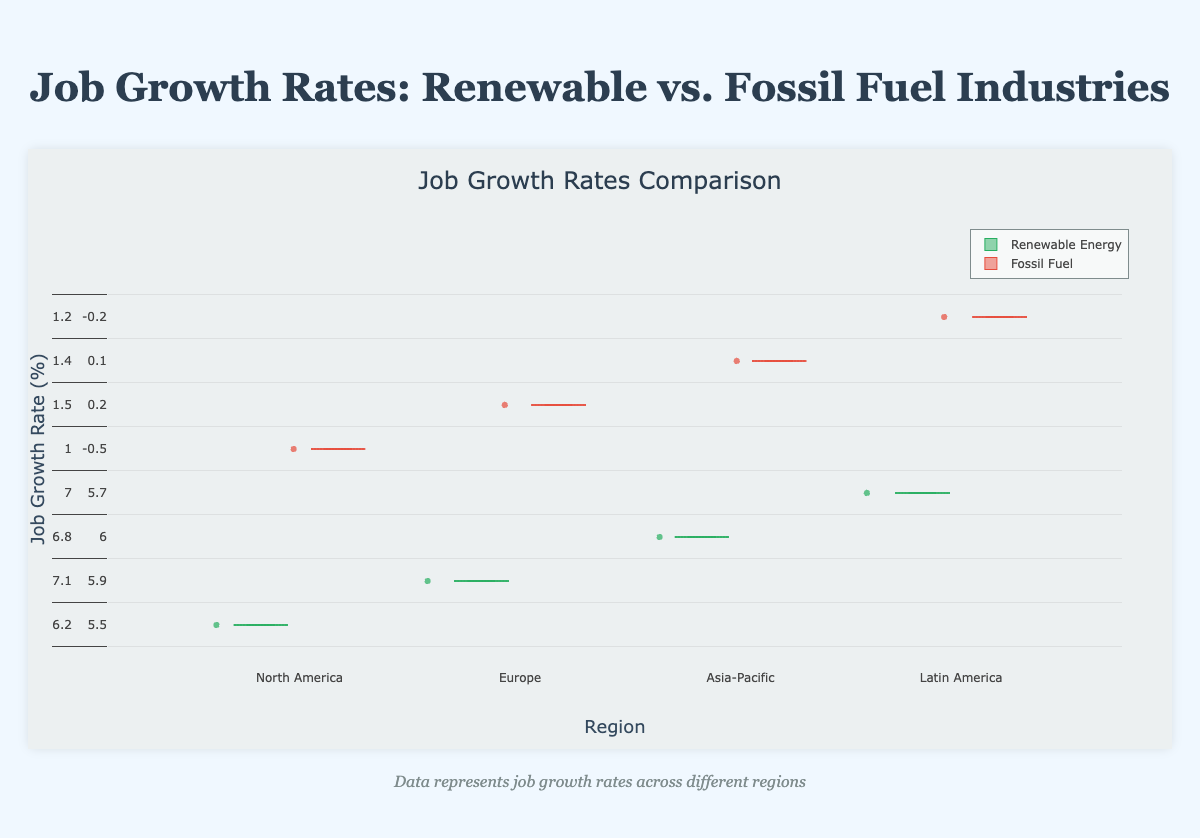What is the title of the chart? The title is prominently displayed at the top of the chart, indicating the main topic or focus of the visualization.
Answer: Job Growth Rates: Renewable vs. Fossil Fuel Industries Which region has the highest median job growth rate for the renewable energy industry? To determine the highest median, compare the middle value of the boxes across all regions for the renewable energy category. The Asia-Pacific box plot has the highest median line when visualizing the renewable energy industry.
Answer: Asia-Pacific What is the range of job growth rates for the fossil fuel industry in North America? The range can be determined by subtracting the minimum value from the maximum value within the box plot whiskers in North America for the fossil fuel industry. Here, the maximum is 1.6%, and the minimum is 1.0%. So, the range is 1.6% - 1.0%.
Answer: 0.6% How does the median job growth rate in Europe for renewable energy compare to that of fossil fuel? Compare the median lines within the box plots for both industries in Europe. The renewable energy median line is around 5.9%, significantly higher than the fossil fuel median line, which is around 0.1%.
Answer: Renewable energy median is higher Which industry shows more variability in job growth rates in the Asia-Pacific region? Variability can be assessed by looking at the interquartile range (IQR) and overall spread of the box plots. For Asia-Pacific, renewable energy has a wider spread and IQR compared to the fossil fuel box plot, indicating more variability.
Answer: Renewable energy What is the interquartile range (IQR) for renewable energy job growth rates in Latin America? The IQR is calculated by subtracting the value at the first quartile (Q1) from the value at the third quartile (Q3). For Latin America, Q3 is around 4.9% and Q1 is around 4.6%. Thus, IQR = 4.9% - 4.6%.
Answer: 0.3% Are there any regions where the job growth rates for fossil fuel are negative? Look at the positions of the box plots for fossil fuel spanning below the zero line. In Europe, the fossil fuel box plot has whiskers dipping below zero, indicating negative job growth rates.
Answer: Europe How does job growth in the renewable energy sector in North America compare to Latin America? Compare the positions and medians of the box plots for renewable energy in North America and Latin America. North America's median is around 6.85%, while Latin America's median is around 4.75%, showing North America has higher growth.
Answer: North America has higher growth In which region is the fossil fuel industry experiencing the most consistent job growth rates? Consistency can be observed through the narrowness and short whiskers of the box plots. North America's fossil fuel box plot is narrow with short whiskers, indicating consistent growth.
Answer: North America Which industry generally experiences higher job growth rates across all regions? By visual inspection, the renewable energy box plots are positioned higher across all regions compared to the fossil fuel box plots, indicating higher overall job growth rates.
Answer: Renewable energy 